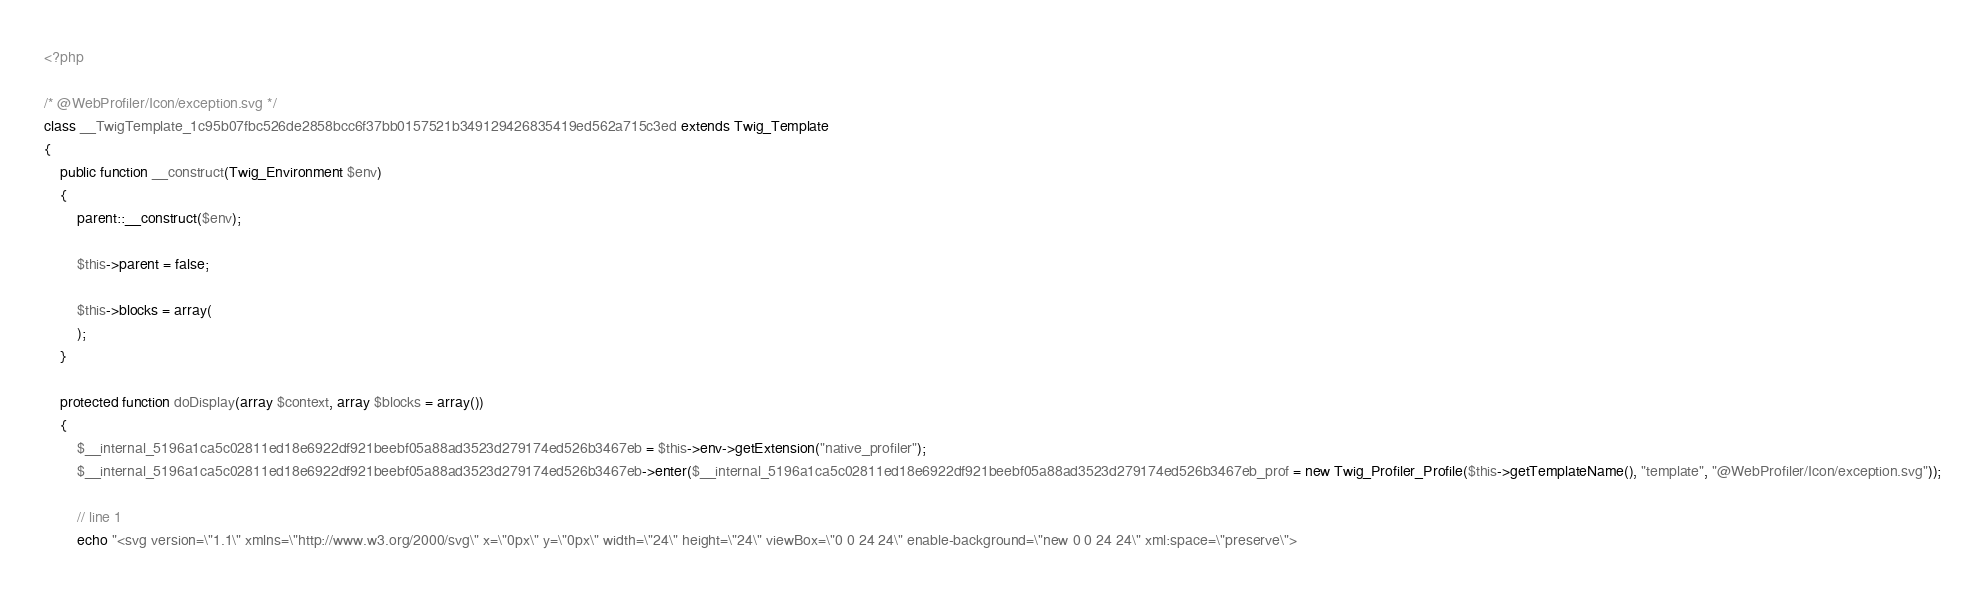Convert code to text. <code><loc_0><loc_0><loc_500><loc_500><_PHP_><?php

/* @WebProfiler/Icon/exception.svg */
class __TwigTemplate_1c95b07fbc526de2858bcc6f37bb0157521b349129426835419ed562a715c3ed extends Twig_Template
{
    public function __construct(Twig_Environment $env)
    {
        parent::__construct($env);

        $this->parent = false;

        $this->blocks = array(
        );
    }

    protected function doDisplay(array $context, array $blocks = array())
    {
        $__internal_5196a1ca5c02811ed18e6922df921beebf05a88ad3523d279174ed526b3467eb = $this->env->getExtension("native_profiler");
        $__internal_5196a1ca5c02811ed18e6922df921beebf05a88ad3523d279174ed526b3467eb->enter($__internal_5196a1ca5c02811ed18e6922df921beebf05a88ad3523d279174ed526b3467eb_prof = new Twig_Profiler_Profile($this->getTemplateName(), "template", "@WebProfiler/Icon/exception.svg"));

        // line 1
        echo "<svg version=\"1.1\" xmlns=\"http://www.w3.org/2000/svg\" x=\"0px\" y=\"0px\" width=\"24\" height=\"24\" viewBox=\"0 0 24 24\" enable-background=\"new 0 0 24 24\" xml:space=\"preserve\"></code> 